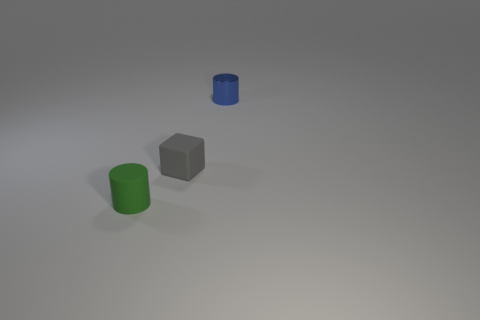Add 1 tiny green metal blocks. How many objects exist? 4 Subtract all cylinders. How many objects are left? 1 Add 1 big blue matte objects. How many big blue matte objects exist? 1 Subtract 0 red cylinders. How many objects are left? 3 Subtract all matte things. Subtract all big purple cylinders. How many objects are left? 1 Add 2 tiny matte things. How many tiny matte things are left? 4 